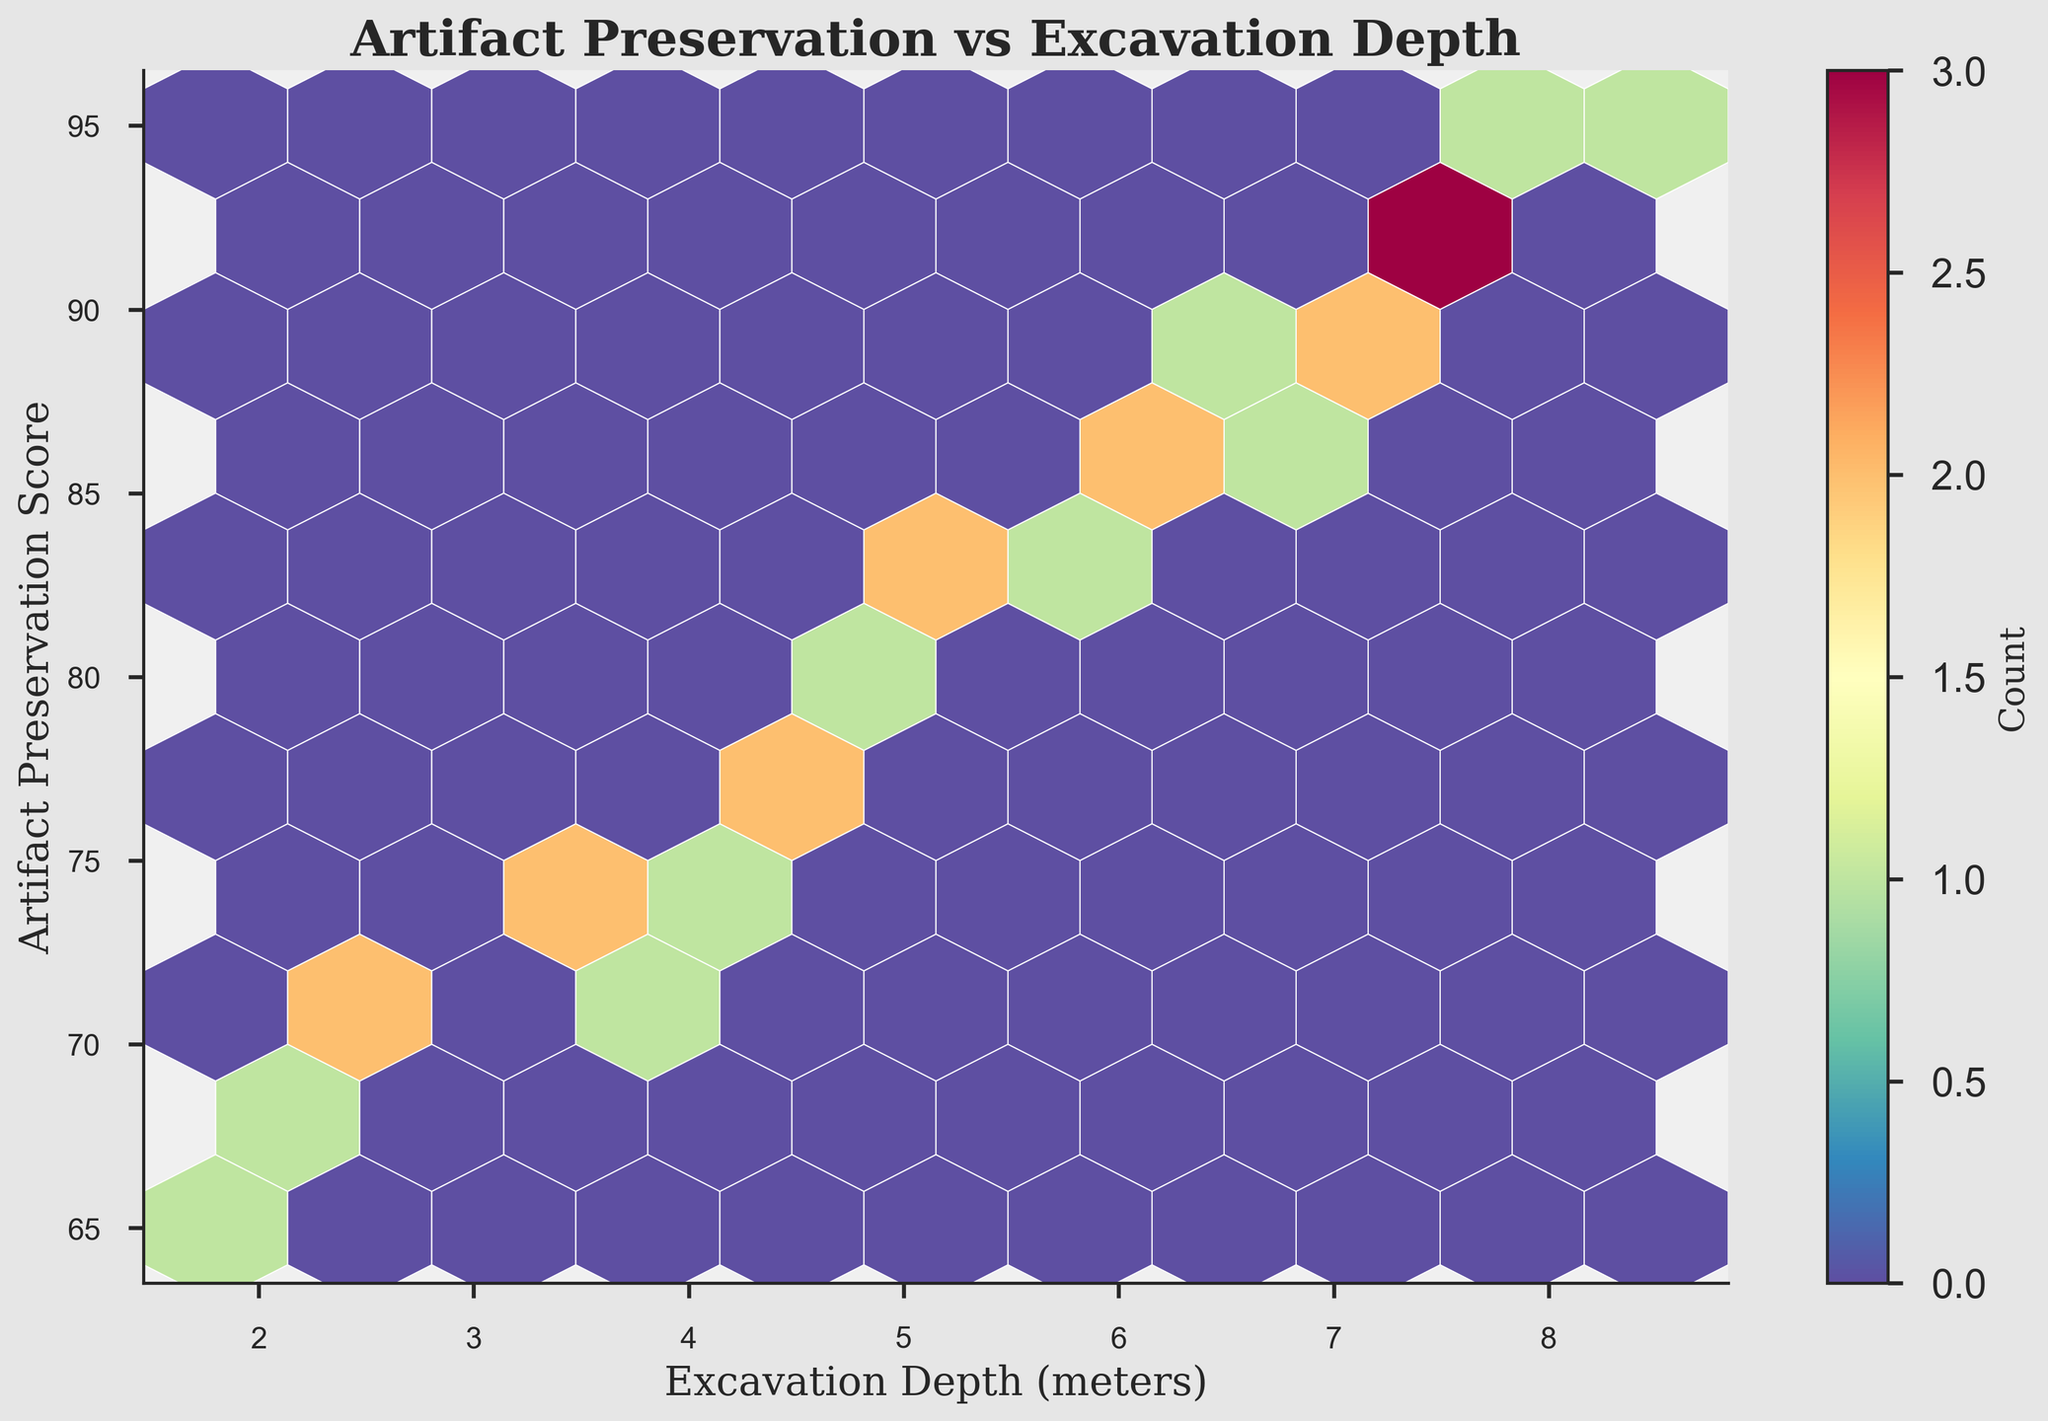What is the title of the hexbin plot? The title of the plot is typically displayed at the top of the figure. The title provides a summary of what the plot is about. In this case, the title reads 'Artifact Preservation vs Excavation Depth'.
Answer: Artifact Preservation vs Excavation Depth What are the labels on the x-axis and y-axis? The labels on the axes indicate what the x and y dimensions represent. The x-axis label is 'Excavation Depth (meters)', and the y-axis label is 'Artifact Preservation Score'.
Answer: Excavation Depth (meters); Artifact Preservation Score How does the color intensity within the hexagons convey information? In a hexbin plot, the color intensity within each hexagon expresses the count of data points within that hexagon's area. A higher intensity indicates a higher count. By examining the color bar, you can see the color scale ranging from low to high counts.
Answer: Intensity shows count Where is the highest density of data points located in terms of depth and preservation score? To find the highest density, look for the darkest or most intense-colored hexagons on the plot. These hexagons are situated where the depth and preservation score axes intersect. The highest density seems to be around a depth of 7 meters and a preservation score of 90.
Answer: Approximately at 7 meters depth and 90 preservation score What is the approximate range of excavation depths observed in the plot? By checking the x-axis, you can observe that the range of excavation depths stretches from around 1.8 meters to about 8.5 meters. These are inferred from the minimum and maximum values.
Answer: 1.8 to 8.5 meters How does artifact preservation score vary with excavation depth? Observing the plot, there seems to be a trend where artifact preservation scores increase with greater excavation depth. This can be seen as data points with higher preservation scores tend to appear more at greater depths.
Answer: Increases with depth Are there any exceptions or outliers where preservation scores do not align with the general trend? Exceptions or outliers are points that deviate from the observable pattern. In the plot, points at around 2.5 meters and 6.5 meters have preservation scores lower than the increasing trend.
Answer: Around 2.5 meters and 6.5 meters Which depth range has the most consistent preservation score? A consistent preservation score appears in the range of 6 to 7 meters where the scores are clustered around high values. This can be observed by the tightly packed high-density hexagons.
Answer: 6 to 7 meters How can you identify areas on the plot where artifact preservation is least likely to be high? Look for areas with the lowest density of color (lightest hexagons). These regions indicate fewer data points and hence lower preservation scores. Such areas can be identified around the lower ranges of both depth and preservation scores.
Answer: Lower depth and preservation scores What can be inferred about the relationship between depth and preservation quality from the hexbin plot? The plot generally suggests a positive correlation between excavation depth and artifact preservation score. As depth increases, the preservation score appears to also increase, indicated by the overall trend of denser hexagons at higher depths and scores.
Answer: Positive correlation 